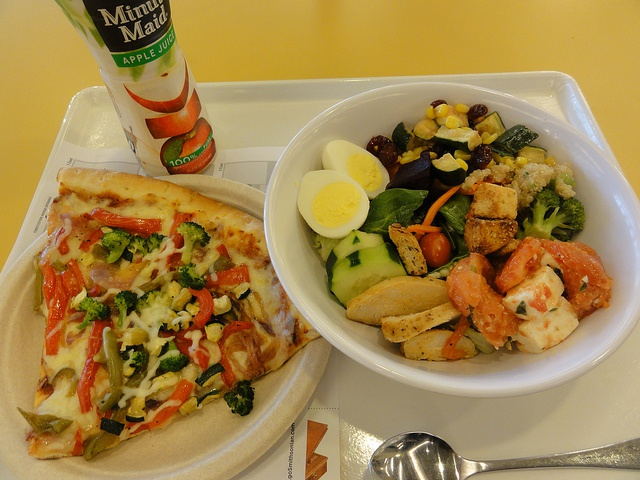Describe the objects in this image and their specific colors. I can see bowl in tan, olive, black, and darkgray tones, pizza in tan and olive tones, bottle in tan, black, brown, and olive tones, spoon in tan and gray tones, and broccoli in tan, olive, and black tones in this image. 